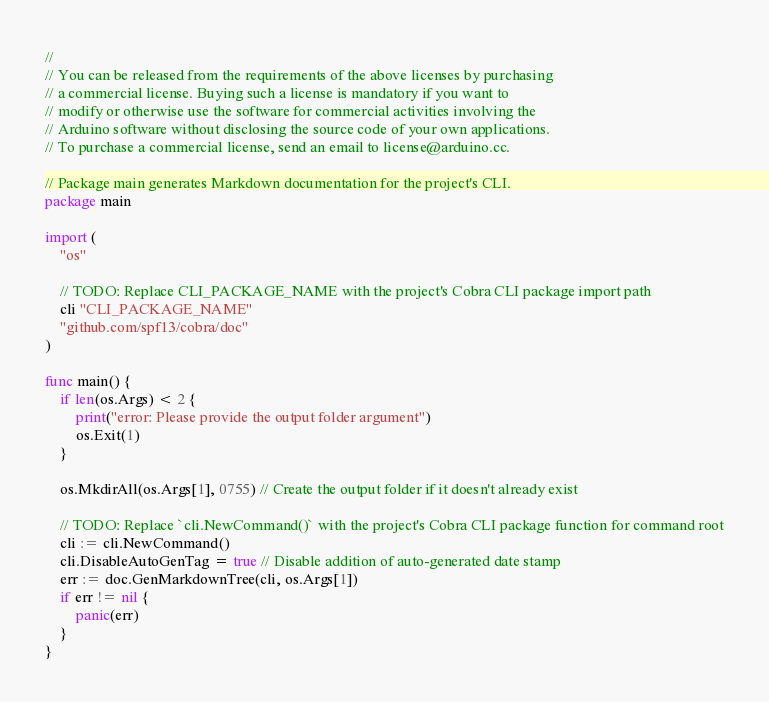Convert code to text. <code><loc_0><loc_0><loc_500><loc_500><_Go_>//
// You can be released from the requirements of the above licenses by purchasing
// a commercial license. Buying such a license is mandatory if you want to
// modify or otherwise use the software for commercial activities involving the
// Arduino software without disclosing the source code of your own applications.
// To purchase a commercial license, send an email to license@arduino.cc.

// Package main generates Markdown documentation for the project's CLI.
package main

import (
	"os"

	// TODO: Replace CLI_PACKAGE_NAME with the project's Cobra CLI package import path
	cli "CLI_PACKAGE_NAME"
	"github.com/spf13/cobra/doc"
)

func main() {
	if len(os.Args) < 2 {
		print("error: Please provide the output folder argument")
		os.Exit(1)
	}

	os.MkdirAll(os.Args[1], 0755) // Create the output folder if it doesn't already exist

	// TODO: Replace `cli.NewCommand()` with the project's Cobra CLI package function for command root
	cli := cli.NewCommand()
	cli.DisableAutoGenTag = true // Disable addition of auto-generated date stamp
	err := doc.GenMarkdownTree(cli, os.Args[1])
	if err != nil {
		panic(err)
	}
}
</code> 